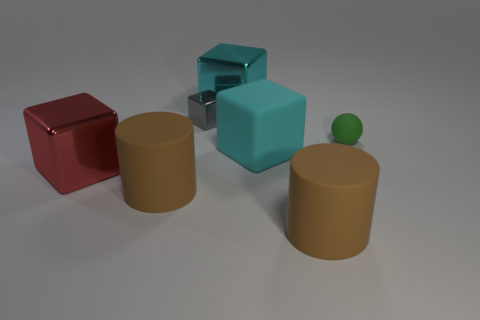Add 3 red shiny things. How many objects exist? 10 Subtract all cubes. How many objects are left? 3 Add 7 big brown cylinders. How many big brown cylinders exist? 9 Subtract all cyan cubes. How many cubes are left? 2 Subtract all big cubes. How many cubes are left? 1 Subtract 0 green cylinders. How many objects are left? 7 Subtract 1 cylinders. How many cylinders are left? 1 Subtract all gray cylinders. Subtract all gray blocks. How many cylinders are left? 2 Subtract all purple spheres. How many gray blocks are left? 1 Subtract all large red metal objects. Subtract all red metal objects. How many objects are left? 5 